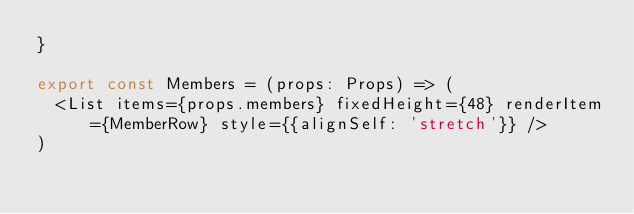Convert code to text. <code><loc_0><loc_0><loc_500><loc_500><_JavaScript_>}

export const Members = (props: Props) => (
  <List items={props.members} fixedHeight={48} renderItem={MemberRow} style={{alignSelf: 'stretch'}} />
)
</code> 